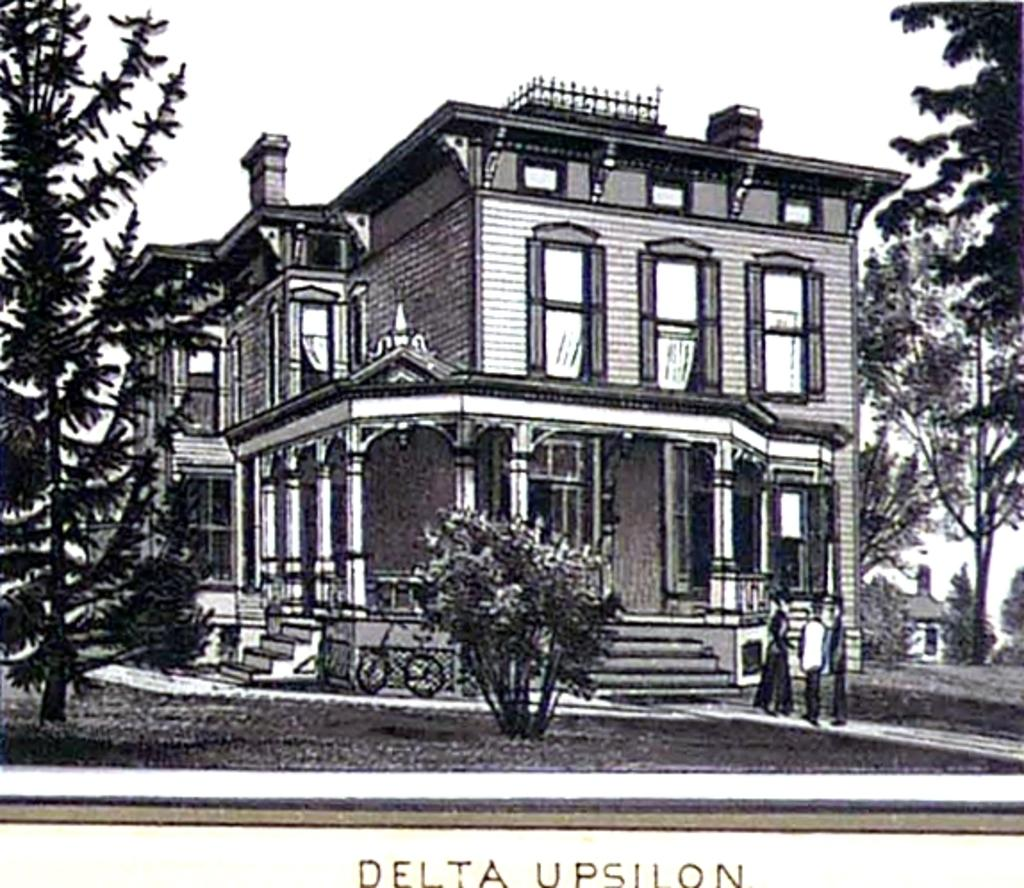What types of living organisms can be seen in the image? People and trees are visible in the image. What structures can be seen in the image? Buildings are visible in the image. What mode of transportation can be seen in the image? There is a bicycle in the image. What else is present in the image besides the people, trees, buildings, and bicycle? There are other unspecified things in the image. What part of the natural environment is visible in the image? The sky is visible in the image. What is written at the bottom of the image? There is text visible at the bottom of the image. How does the image show an increase in the number of units in the bedroom? The image does not show any bedrooms or units; it features people, trees, buildings, a bicycle, and other unspecified things. 